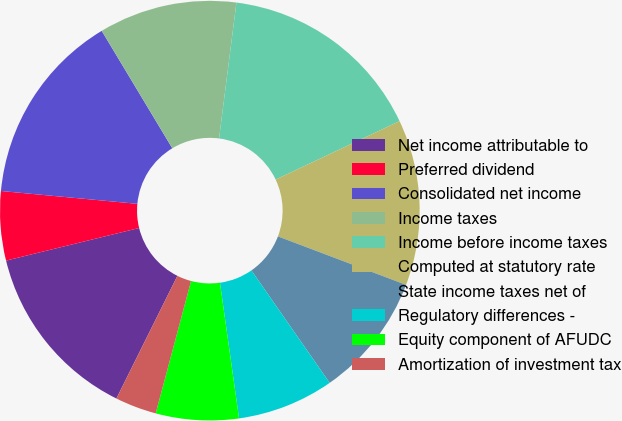<chart> <loc_0><loc_0><loc_500><loc_500><pie_chart><fcel>Net income attributable to<fcel>Preferred dividend<fcel>Consolidated net income<fcel>Income taxes<fcel>Income before income taxes<fcel>Computed at statutory rate<fcel>State income taxes net of<fcel>Regulatory differences -<fcel>Equity component of AFUDC<fcel>Amortization of investment tax<nl><fcel>13.83%<fcel>5.32%<fcel>14.89%<fcel>10.64%<fcel>15.96%<fcel>12.77%<fcel>9.57%<fcel>7.45%<fcel>6.38%<fcel>3.19%<nl></chart> 